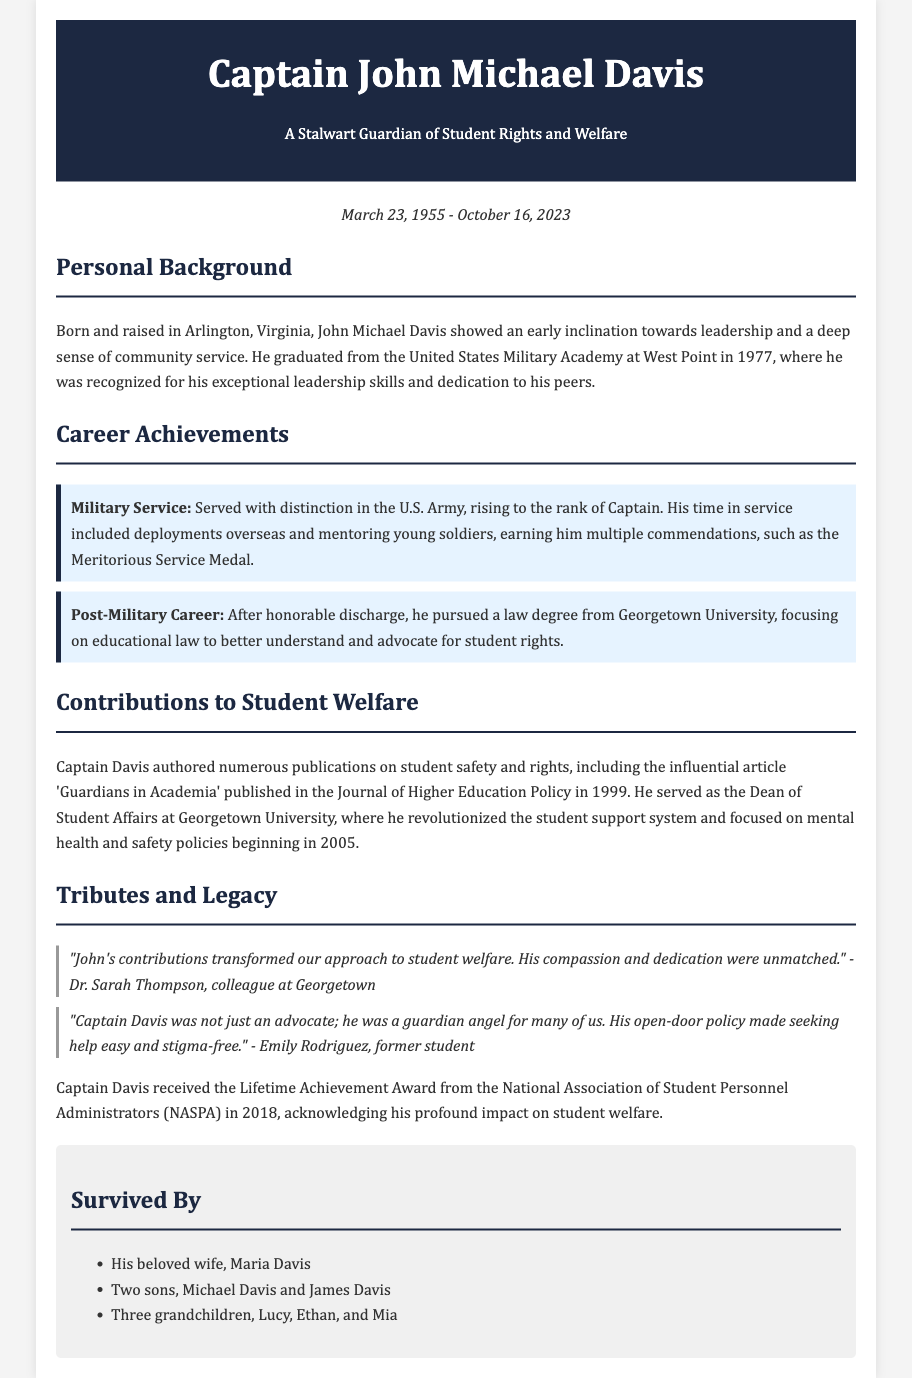What is the full name of the individual celebrated in the obituary? The full name is mentioned in the title of the document, which is "Captain John Michael Davis".
Answer: Captain John Michael Davis What was the date of birth of Captain John M. Davis? The document states that he was born on March 23, 1955.
Answer: March 23, 1955 What notable medal did Captain Davis receive during his military service? A specific military commendation is highlighted in the document, which is the Meritorious Service Medal.
Answer: Meritorious Service Medal What position did Captain Davis hold at Georgetown University? The document specifies that he served as the Dean of Student Affairs at Georgetown University.
Answer: Dean of Student Affairs What year was Captain Davis awarded the Lifetime Achievement Award from NASPA? The year of the award is mentioned in the tribute section of the document, noted as 2018.
Answer: 2018 Which article did Captain Davis author that contributed to student welfare discussions? The title of the influential article authored by Captain Davis is 'Guardians in Academia'.
Answer: Guardians in Academia What was a key focus of Captain Davis's advocacy for student welfare? The document mentions that he focused on mental health and safety policies.
Answer: Mental health and safety policies Who is mentioned as a colleague that provided a tribute to Captain Davis? The document lists Dr. Sarah Thompson as a colleague who provided a tribute.
Answer: Dr. Sarah Thompson How many grandchildren did Captain Davis have? The document states that he had three grandchildren.
Answer: Three grandchildren 